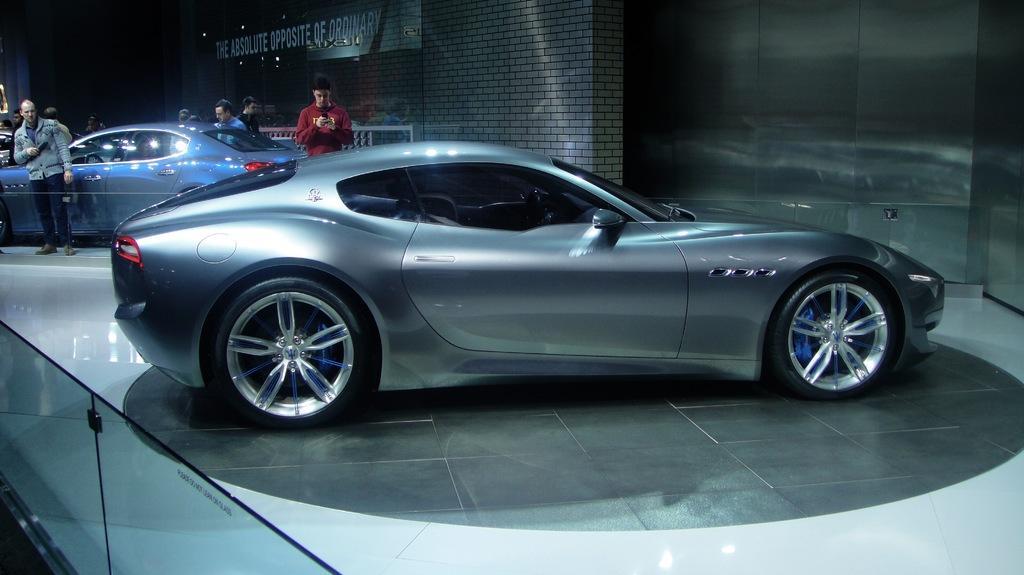Describe this image in one or two sentences. In the picture I can see the cars on the road. I can see the glass fencing on the bottom left side. I can see a man on the left side and he is having a look at the car on the floor. I can see another man on the right side and looks like he is holding a mobile phone in his hands. In the background, I can see a few persons. 